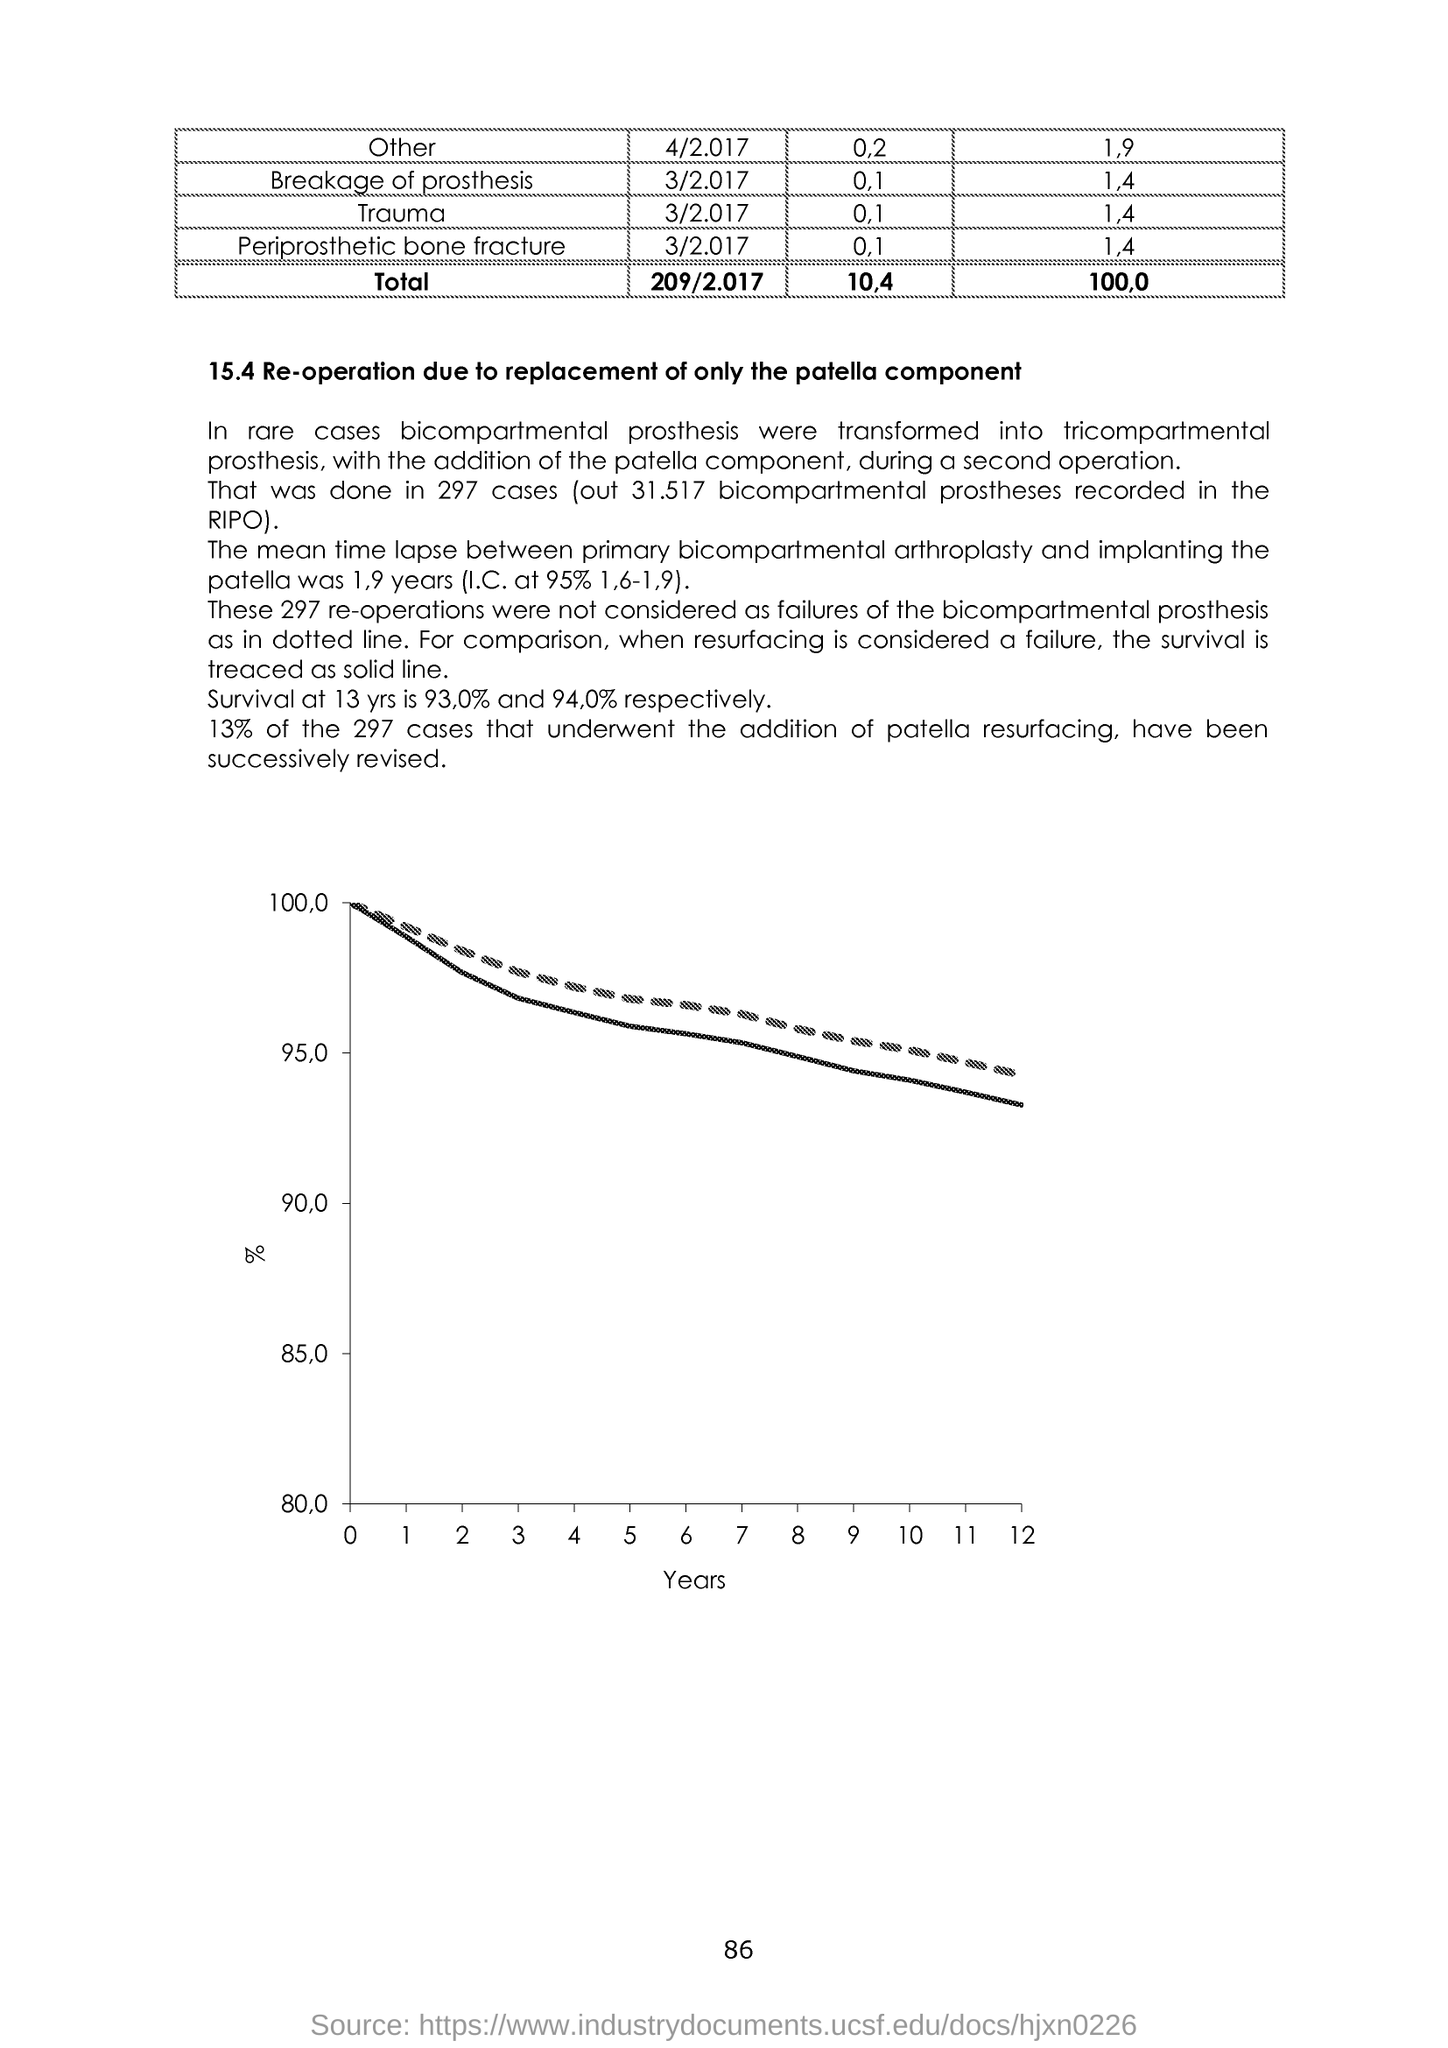Specify some key components in this picture. The number at the bottom of the page is 86. The x-axis of the graph displays the years. 